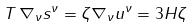Convert formula to latex. <formula><loc_0><loc_0><loc_500><loc_500>T \, \nabla _ { \nu } s ^ { \nu } = \zeta \nabla _ { \nu } u ^ { \nu } = 3 H \zeta</formula> 